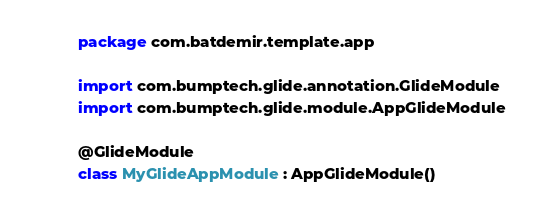Convert code to text. <code><loc_0><loc_0><loc_500><loc_500><_Kotlin_>package com.batdemir.template.app

import com.bumptech.glide.annotation.GlideModule
import com.bumptech.glide.module.AppGlideModule

@GlideModule
class MyGlideAppModule : AppGlideModule()
</code> 